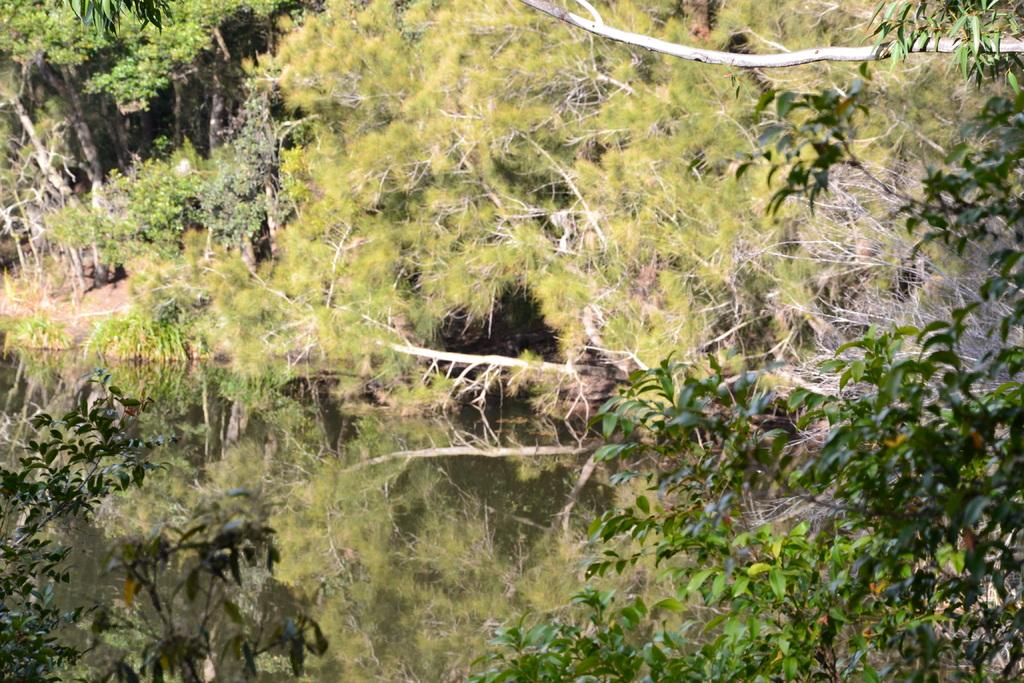What is the primary element visible in the picture? There is water in the picture. What type of vegetation can be seen in the picture? There are plants and trees in the picture. What type of fan is visible in the picture? There is no fan present in the picture. Can you tell me where the committee is meeting in the picture? There is no committee or meeting place visible in the picture. 